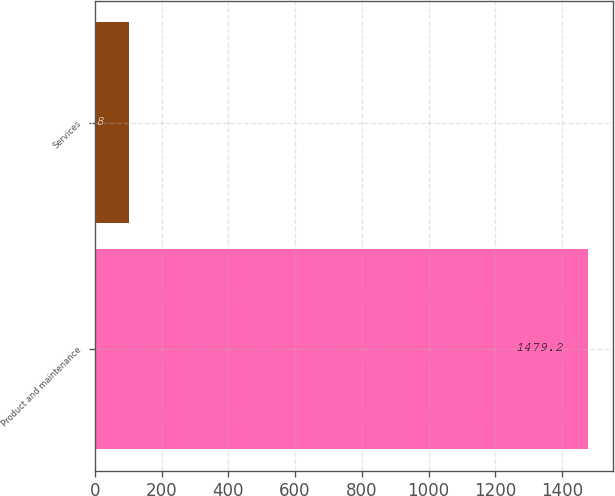Convert chart to OTSL. <chart><loc_0><loc_0><loc_500><loc_500><bar_chart><fcel>Product and maintenance<fcel>Services<nl><fcel>1479.2<fcel>101.8<nl></chart> 